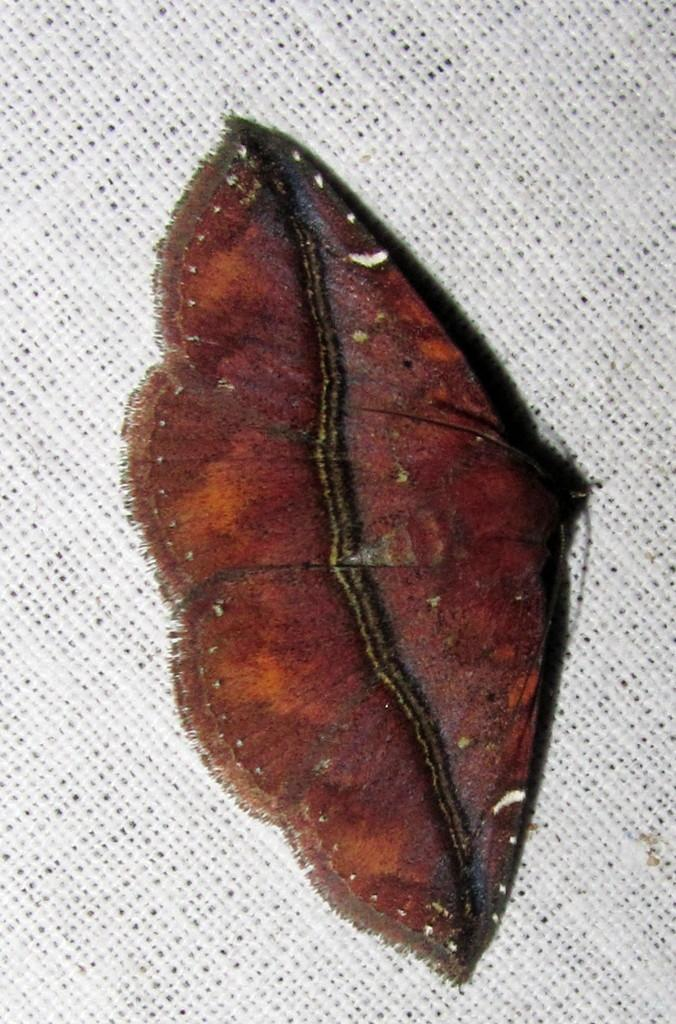What type of creature is in the image? There is a brown insect in the image. What is the color of the surface where the insect is located? The insect is on a white surface. How many pies are floating in the lake in the image? There are no pies or lakes present in the image; it features a brown insect on a white surface. 